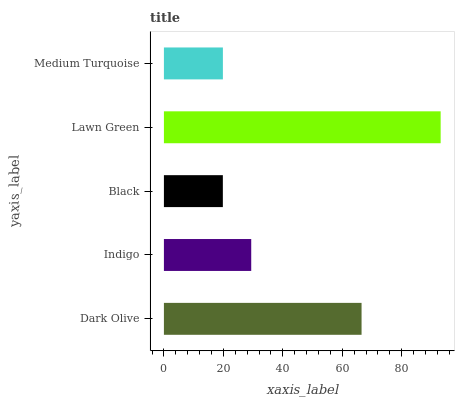Is Black the minimum?
Answer yes or no. Yes. Is Lawn Green the maximum?
Answer yes or no. Yes. Is Indigo the minimum?
Answer yes or no. No. Is Indigo the maximum?
Answer yes or no. No. Is Dark Olive greater than Indigo?
Answer yes or no. Yes. Is Indigo less than Dark Olive?
Answer yes or no. Yes. Is Indigo greater than Dark Olive?
Answer yes or no. No. Is Dark Olive less than Indigo?
Answer yes or no. No. Is Indigo the high median?
Answer yes or no. Yes. Is Indigo the low median?
Answer yes or no. Yes. Is Dark Olive the high median?
Answer yes or no. No. Is Lawn Green the low median?
Answer yes or no. No. 